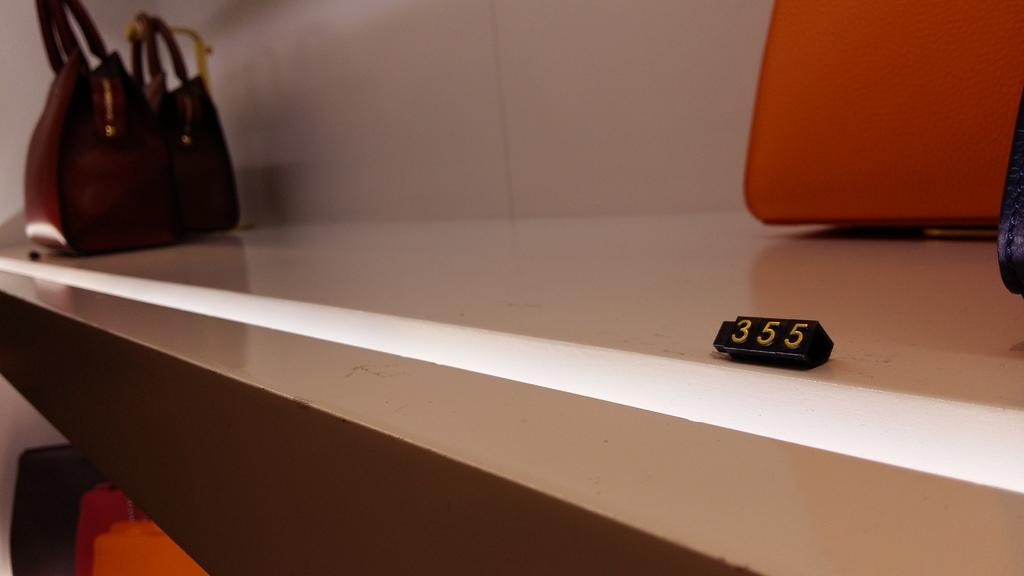What object can be seen in the image that might be used for carrying items? There is a bag in the image that might be used for carrying items. What type of board is present in the image? There is a number board in the image. What color is the request made by the person in the image? There is no person making a request in the image, and therefore no such color can be determined. 